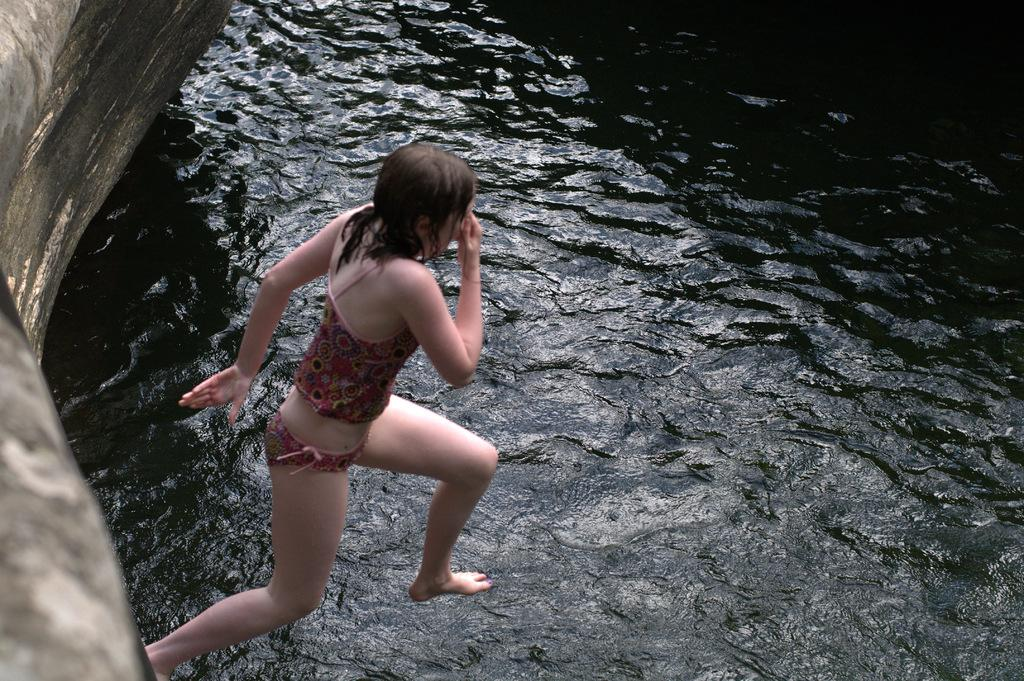Who is the main subject in the image? There is a lady in the image. What is the lady doing in the image? The lady is jumping into the water. What can be seen in the background of the image? There is water visible in the image. Is there any architectural feature in the image? Yes, there is a wall in the left corner of the image. How many sheep are visible in the image? There are no sheep present in the image. What type of bridge can be seen in the image? There is no bridge present in the image. 